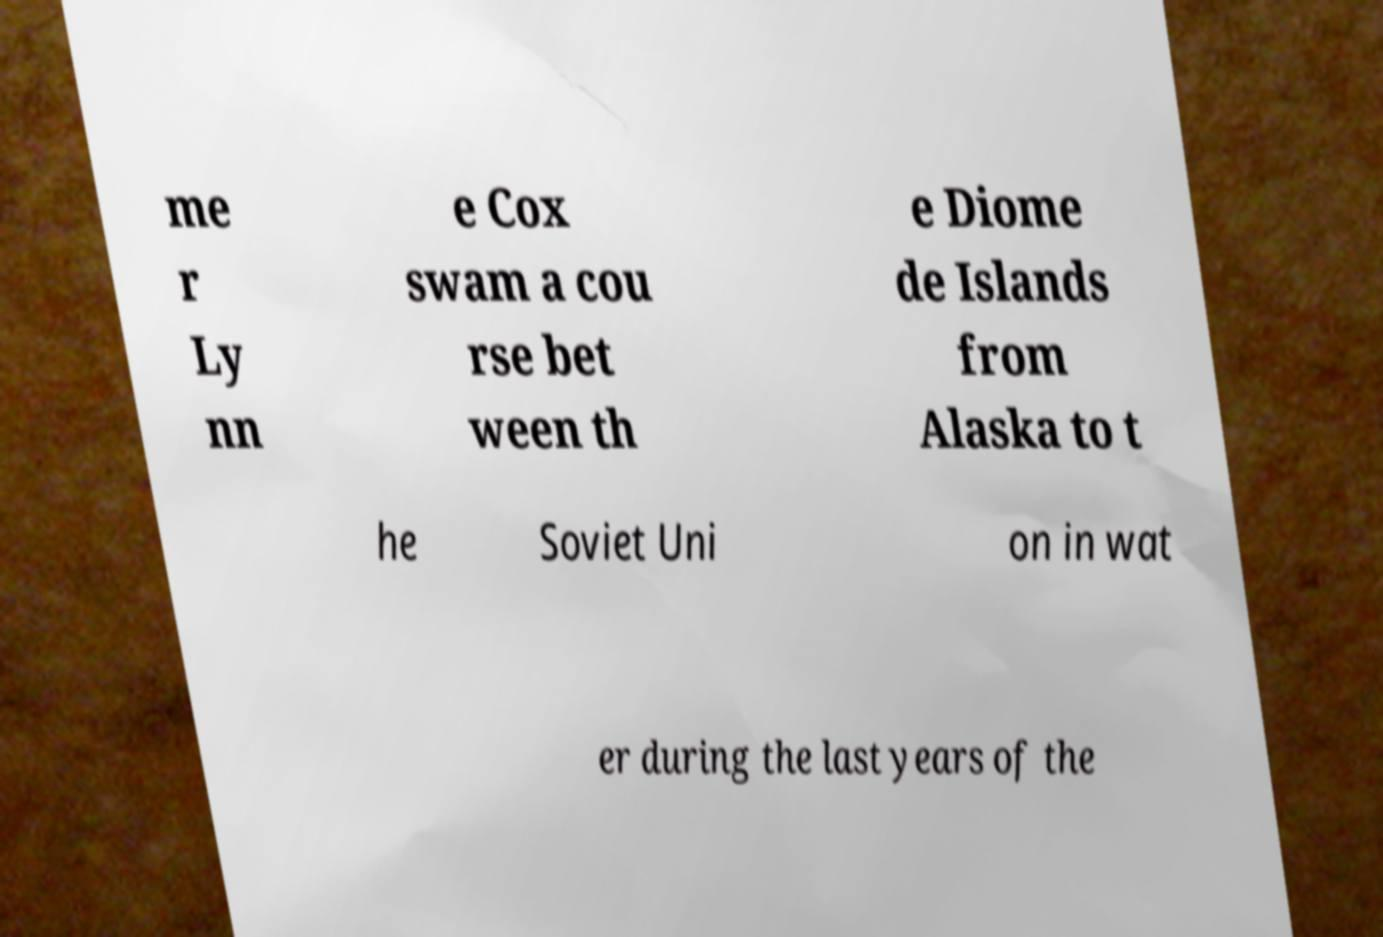For documentation purposes, I need the text within this image transcribed. Could you provide that? me r Ly nn e Cox swam a cou rse bet ween th e Diome de Islands from Alaska to t he Soviet Uni on in wat er during the last years of the 